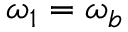Convert formula to latex. <formula><loc_0><loc_0><loc_500><loc_500>\omega _ { 1 } = \omega _ { b }</formula> 